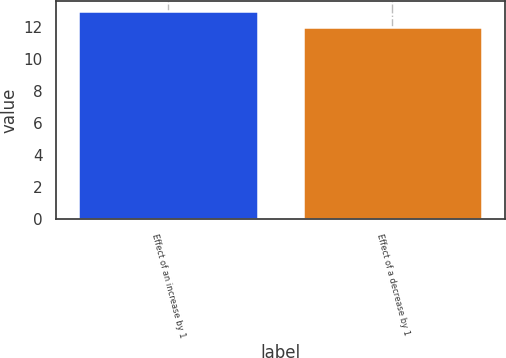Convert chart. <chart><loc_0><loc_0><loc_500><loc_500><bar_chart><fcel>Effect of an increase by 1<fcel>Effect of a decrease by 1<nl><fcel>13<fcel>12<nl></chart> 